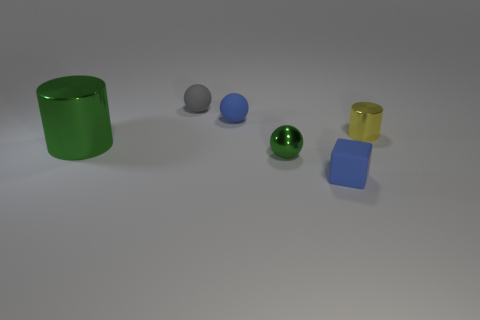What shape is the big object that is the same color as the tiny metallic sphere?
Your response must be concise. Cylinder. How many metallic things are in front of the metal object that is behind the large metallic cylinder?
Give a very brief answer. 2. Does the green cylinder have the same material as the green ball?
Your answer should be very brief. Yes. What number of objects are in front of the blue thing behind the matte object in front of the big green metallic cylinder?
Your response must be concise. 4. What color is the tiny thing on the right side of the rubber block?
Offer a terse response. Yellow. There is a tiny blue thing behind the green object that is on the right side of the tiny blue ball; what shape is it?
Provide a short and direct response. Sphere. Is the color of the big thing the same as the metallic sphere?
Provide a succinct answer. Yes. How many blocks are either green matte things or green things?
Your response must be concise. 0. There is a small thing that is in front of the small metal cylinder and behind the blue rubber block; what material is it made of?
Give a very brief answer. Metal. There is a small matte cube; how many rubber things are on the left side of it?
Your response must be concise. 2. 